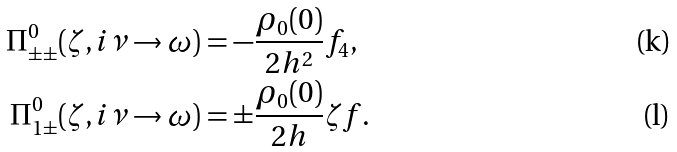Convert formula to latex. <formula><loc_0><loc_0><loc_500><loc_500>\Pi ^ { 0 } _ { \pm \pm } ( \zeta , i \nu \to \omega ) & = - \frac { \rho _ { 0 } ( 0 ) } { 2 h ^ { 2 } } f _ { 4 } , \\ \Pi ^ { 0 } _ { 1 \pm } ( \zeta , i \nu \to \omega ) & = \pm \frac { \rho _ { 0 } ( 0 ) } { 2 h } \zeta f .</formula> 